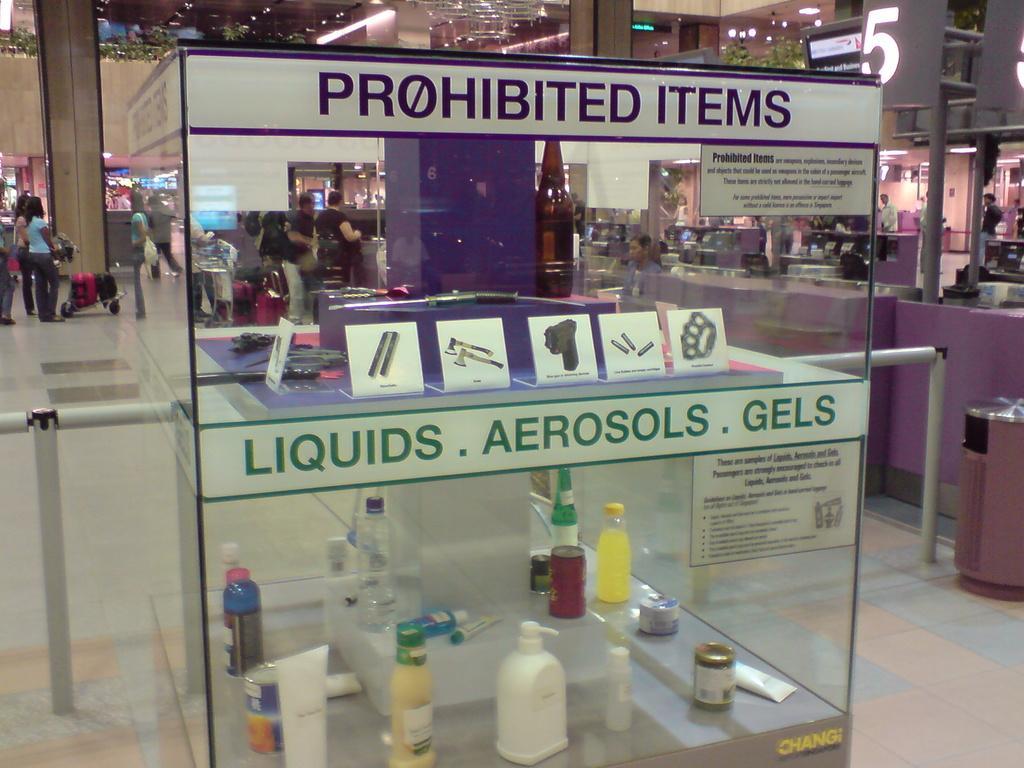In one or two sentences, can you explain what this image depicts? The photo is inside a mall. In the glass box there are some bottles and other things. It written prohibited items, liquid, aerosols,and gels on the box. In the right there are counters. There are many people in the image. 